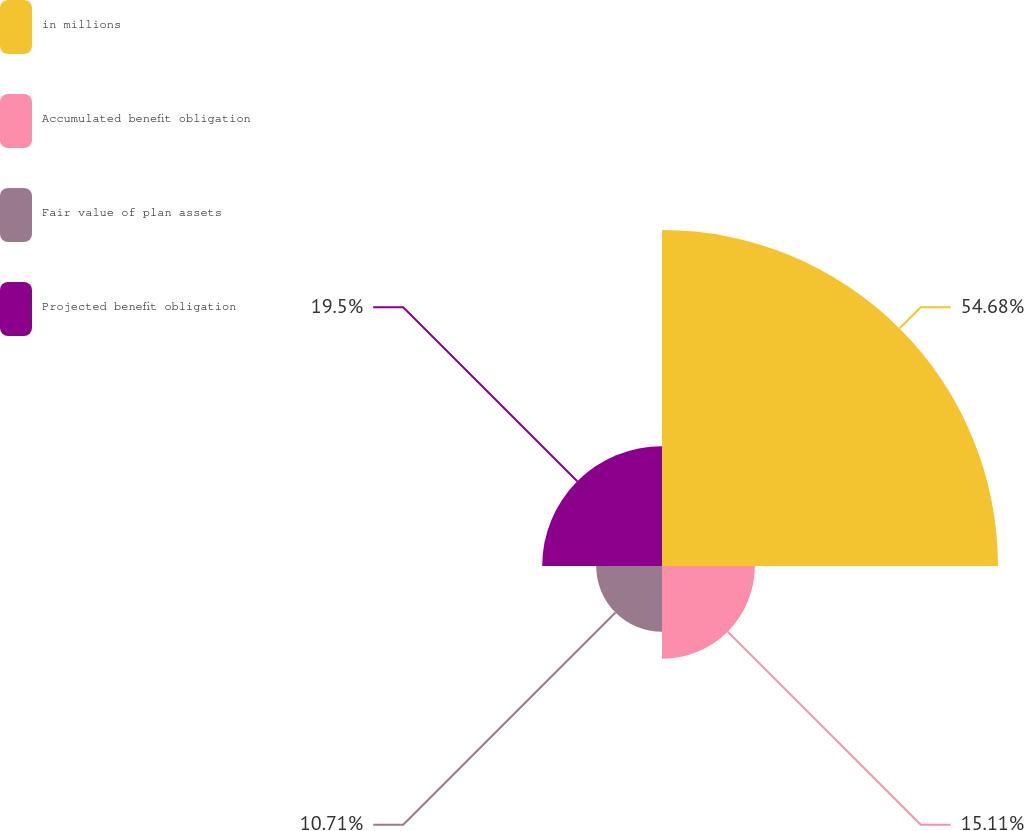<chart> <loc_0><loc_0><loc_500><loc_500><pie_chart><fcel>in millions<fcel>Accumulated benefit obligation<fcel>Fair value of plan assets<fcel>Projected benefit obligation<nl><fcel>54.68%<fcel>15.11%<fcel>10.71%<fcel>19.5%<nl></chart> 